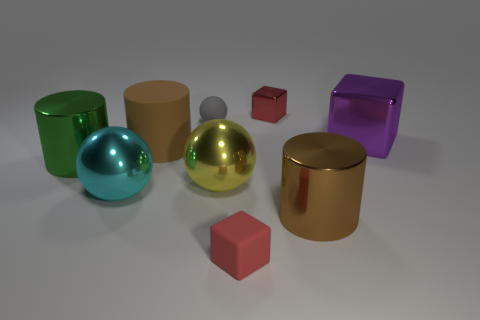Subtract all green cylinders. Subtract all gray blocks. How many cylinders are left? 2 Subtract all yellow cylinders. How many brown balls are left? 0 Add 2 small objects. How many small reds exist? 0 Subtract all big green things. Subtract all brown matte cylinders. How many objects are left? 7 Add 6 tiny gray spheres. How many tiny gray spheres are left? 7 Add 1 cyan metallic blocks. How many cyan metallic blocks exist? 1 Add 1 small green metallic cylinders. How many objects exist? 10 Subtract all brown cylinders. How many cylinders are left? 1 Subtract all rubber blocks. How many blocks are left? 2 Subtract 0 gray cylinders. How many objects are left? 9 